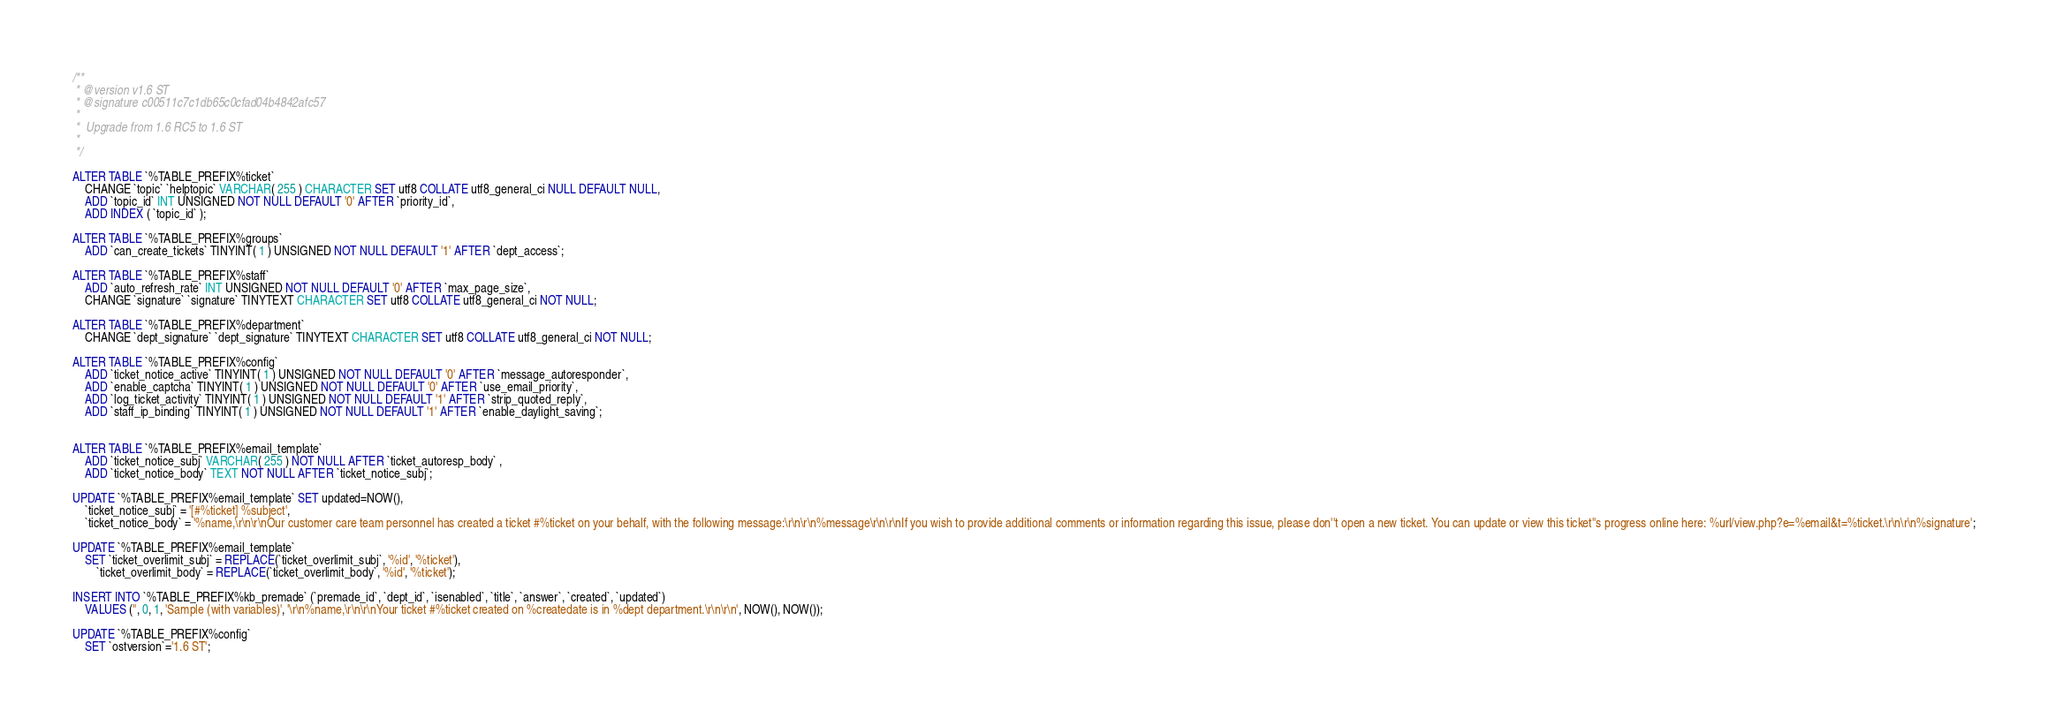Convert code to text. <code><loc_0><loc_0><loc_500><loc_500><_SQL_>/**
 * @version v1.6 ST
 * @signature c00511c7c1db65c0cfad04b4842afc57
 *
 *  Upgrade from 1.6 RC5 to 1.6 ST
 *  
 */

ALTER TABLE `%TABLE_PREFIX%ticket` 
    CHANGE `topic` `helptopic` VARCHAR( 255 ) CHARACTER SET utf8 COLLATE utf8_general_ci NULL DEFAULT NULL,
    ADD `topic_id` INT UNSIGNED NOT NULL DEFAULT '0' AFTER `priority_id`,
    ADD INDEX ( `topic_id` );

ALTER TABLE `%TABLE_PREFIX%groups` 
    ADD `can_create_tickets` TINYINT( 1 ) UNSIGNED NOT NULL DEFAULT '1' AFTER `dept_access`;

ALTER TABLE `%TABLE_PREFIX%staff` 
    ADD `auto_refresh_rate` INT UNSIGNED NOT NULL DEFAULT '0' AFTER `max_page_size`,
    CHANGE `signature` `signature` TINYTEXT CHARACTER SET utf8 COLLATE utf8_general_ci NOT NULL;

ALTER TABLE `%TABLE_PREFIX%department`
    CHANGE `dept_signature` `dept_signature` TINYTEXT CHARACTER SET utf8 COLLATE utf8_general_ci NOT NULL;

ALTER TABLE `%TABLE_PREFIX%config`
    ADD `ticket_notice_active` TINYINT( 1 ) UNSIGNED NOT NULL DEFAULT '0' AFTER `message_autoresponder`,
    ADD `enable_captcha` TINYINT( 1 ) UNSIGNED NOT NULL DEFAULT '0' AFTER `use_email_priority`,
    ADD `log_ticket_activity` TINYINT( 1 ) UNSIGNED NOT NULL DEFAULT '1' AFTER `strip_quoted_reply`,
    ADD `staff_ip_binding` TINYINT( 1 ) UNSIGNED NOT NULL DEFAULT '1' AFTER `enable_daylight_saving`;


ALTER TABLE `%TABLE_PREFIX%email_template`
    ADD `ticket_notice_subj` VARCHAR( 255 ) NOT NULL AFTER `ticket_autoresp_body` ,
    ADD `ticket_notice_body` TEXT NOT NULL AFTER `ticket_notice_subj`;

UPDATE `%TABLE_PREFIX%email_template` SET updated=NOW(),
    `ticket_notice_subj` = '[#%ticket] %subject',
    `ticket_notice_body` = '%name,\r\n\r\nOur customer care team personnel has created a ticket #%ticket on your behalf, with the following message:\r\n\r\n%message\r\n\r\nIf you wish to provide additional comments or information regarding this issue, please don''t open a new ticket. You can update or view this ticket''s progress online here: %url/view.php?e=%email&t=%ticket.\r\n\r\n%signature';

UPDATE `%TABLE_PREFIX%email_template`
    SET `ticket_overlimit_subj` = REPLACE(`ticket_overlimit_subj`, '%id', '%ticket'),
        `ticket_overlimit_body` = REPLACE(`ticket_overlimit_body`, '%id', '%ticket');

INSERT INTO `%TABLE_PREFIX%kb_premade` (`premade_id`, `dept_id`, `isenabled`, `title`, `answer`, `created`, `updated`) 
    VALUES ('', 0, 1, 'Sample (with variables)', '\r\n%name,\r\n\r\nYour ticket #%ticket created on %createdate is in %dept department.\r\n\r\n', NOW(), NOW());

UPDATE `%TABLE_PREFIX%config`
    SET `ostversion`='1.6 ST';
</code> 